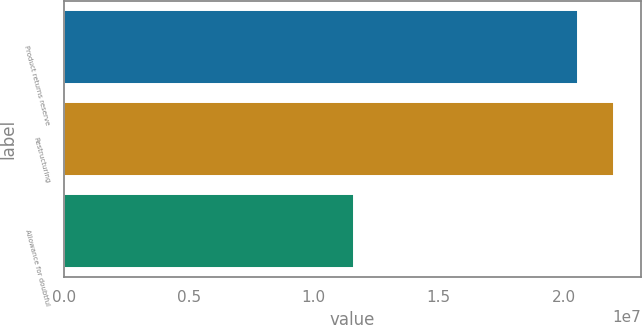Convert chart to OTSL. <chart><loc_0><loc_0><loc_500><loc_500><bar_chart><fcel>Product returns reserve<fcel>Restructuring<fcel>Allowance for doubtful<nl><fcel>2.0578e+07<fcel>2.2002e+07<fcel>1.1611e+07<nl></chart> 